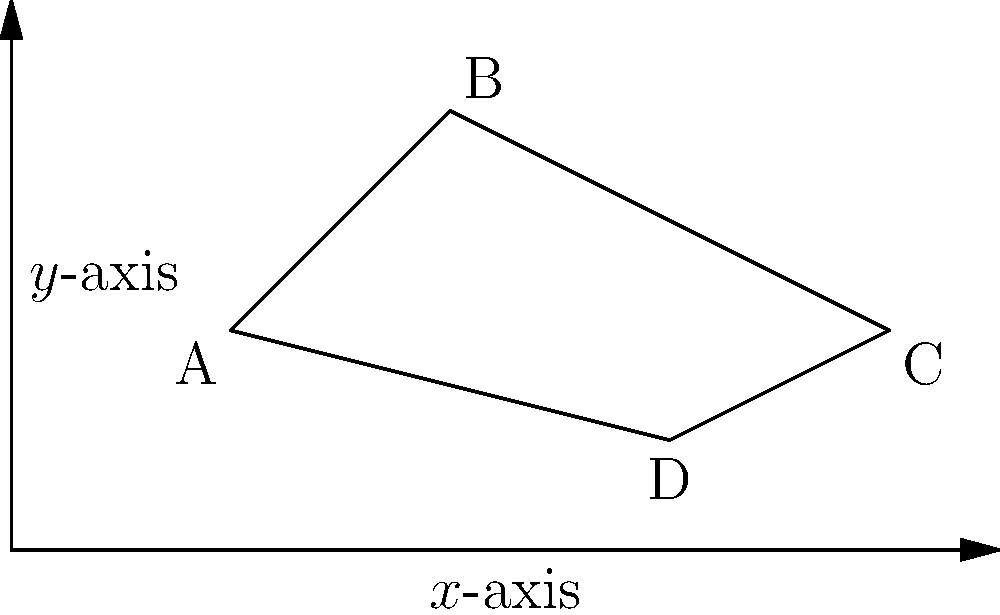In the upper half-plane model of hyperbolic geometry, consider a quadrilateral ABCD with vertices A(1,1), B(2,2), C(4,1), and D(3,0.5). Calculate the hyperbolic area of this quadrilateral. To find the hyperbolic area of the quadrilateral ABCD in the upper half-plane model, we'll follow these steps:

1) In the upper half-plane model, the hyperbolic area of a region is given by the formula:

   $$\text{Area} = \iint_R \frac{dxdy}{y^2}$$

2) For a quadrilateral, we can use the formula:

   $$\text{Area} = \pi - (\alpha + \beta + \gamma + \delta)$$

   where $\alpha, \beta, \gamma, \delta$ are the hyperbolic angles at each vertex.

3) In the upper half-plane model, the hyperbolic angle between two lines intersecting at point $(x,y)$ is the same as the Euclidean angle between these lines.

4) To find these angles, we can use the formula:

   $$\cos \theta = \frac{|(x_2-x_1)(x_3-x_1) + (y_2-y_1)(y_3-y_1)|}{\sqrt{(x_2-x_1)^2 + (y_2-y_1)^2} \sqrt{(x_3-x_1)^2 + (y_3-y_1)^2}}$$

5) Calculating each angle:

   At A: $\alpha = \arccos(\frac{5}{\sqrt{26}\sqrt{10}}) \approx 0.3398$
   At B: $\beta = \arccos(\frac{3}{\sqrt{5}\sqrt{13}}) \approx 0.6435$
   At C: $\gamma = \arccos(\frac{7}{\sqrt{10}\sqrt{10}}) \approx 0.6435$
   At D: $\delta = \arccos(\frac{11}{\sqrt{65}\sqrt{10}}) \approx 0.8480$

6) Sum of angles: $\alpha + \beta + \gamma + \delta \approx 2.4748$

7) Therefore, the hyperbolic area is:

   $$\text{Area} = \pi - 2.4748 \approx 0.6668$$
Answer: $0.6668$ square units 